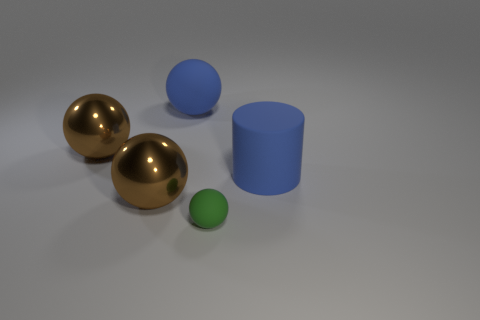What might be the sizes of these objects? It's challenging to determine the exact sizes without a reference point, but the larger spheres seem to be roughly equal in size, noticeably larger than the tiny matte sphere, and the blue cylinder appears to be of a similar diameter to the spheres but with a shorter height. 